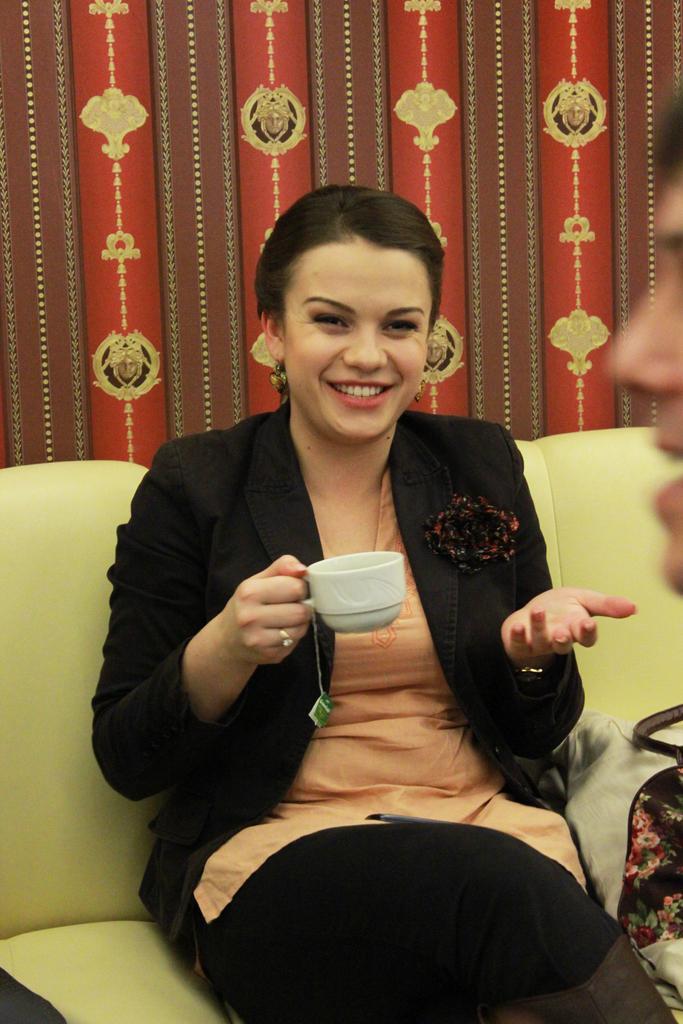Can you describe this image briefly? In this picture woman is sitting in the center on a sofa holding a cup in her hand and having a smile on her face. In the background there is red colour curtain. At the right side partially face is visible of a man. 